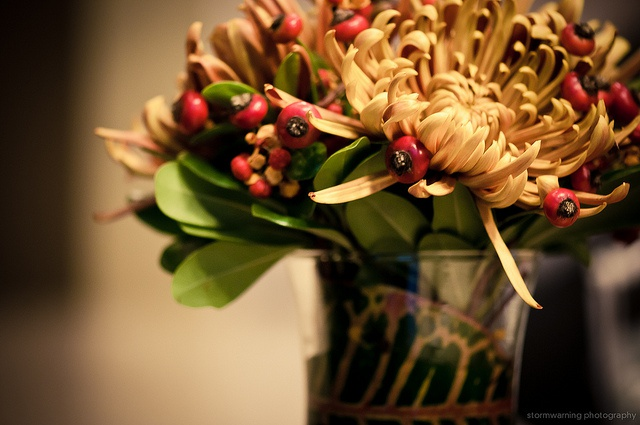Describe the objects in this image and their specific colors. I can see potted plant in black, maroon, brown, and olive tones and vase in black, maroon, olive, and gray tones in this image. 